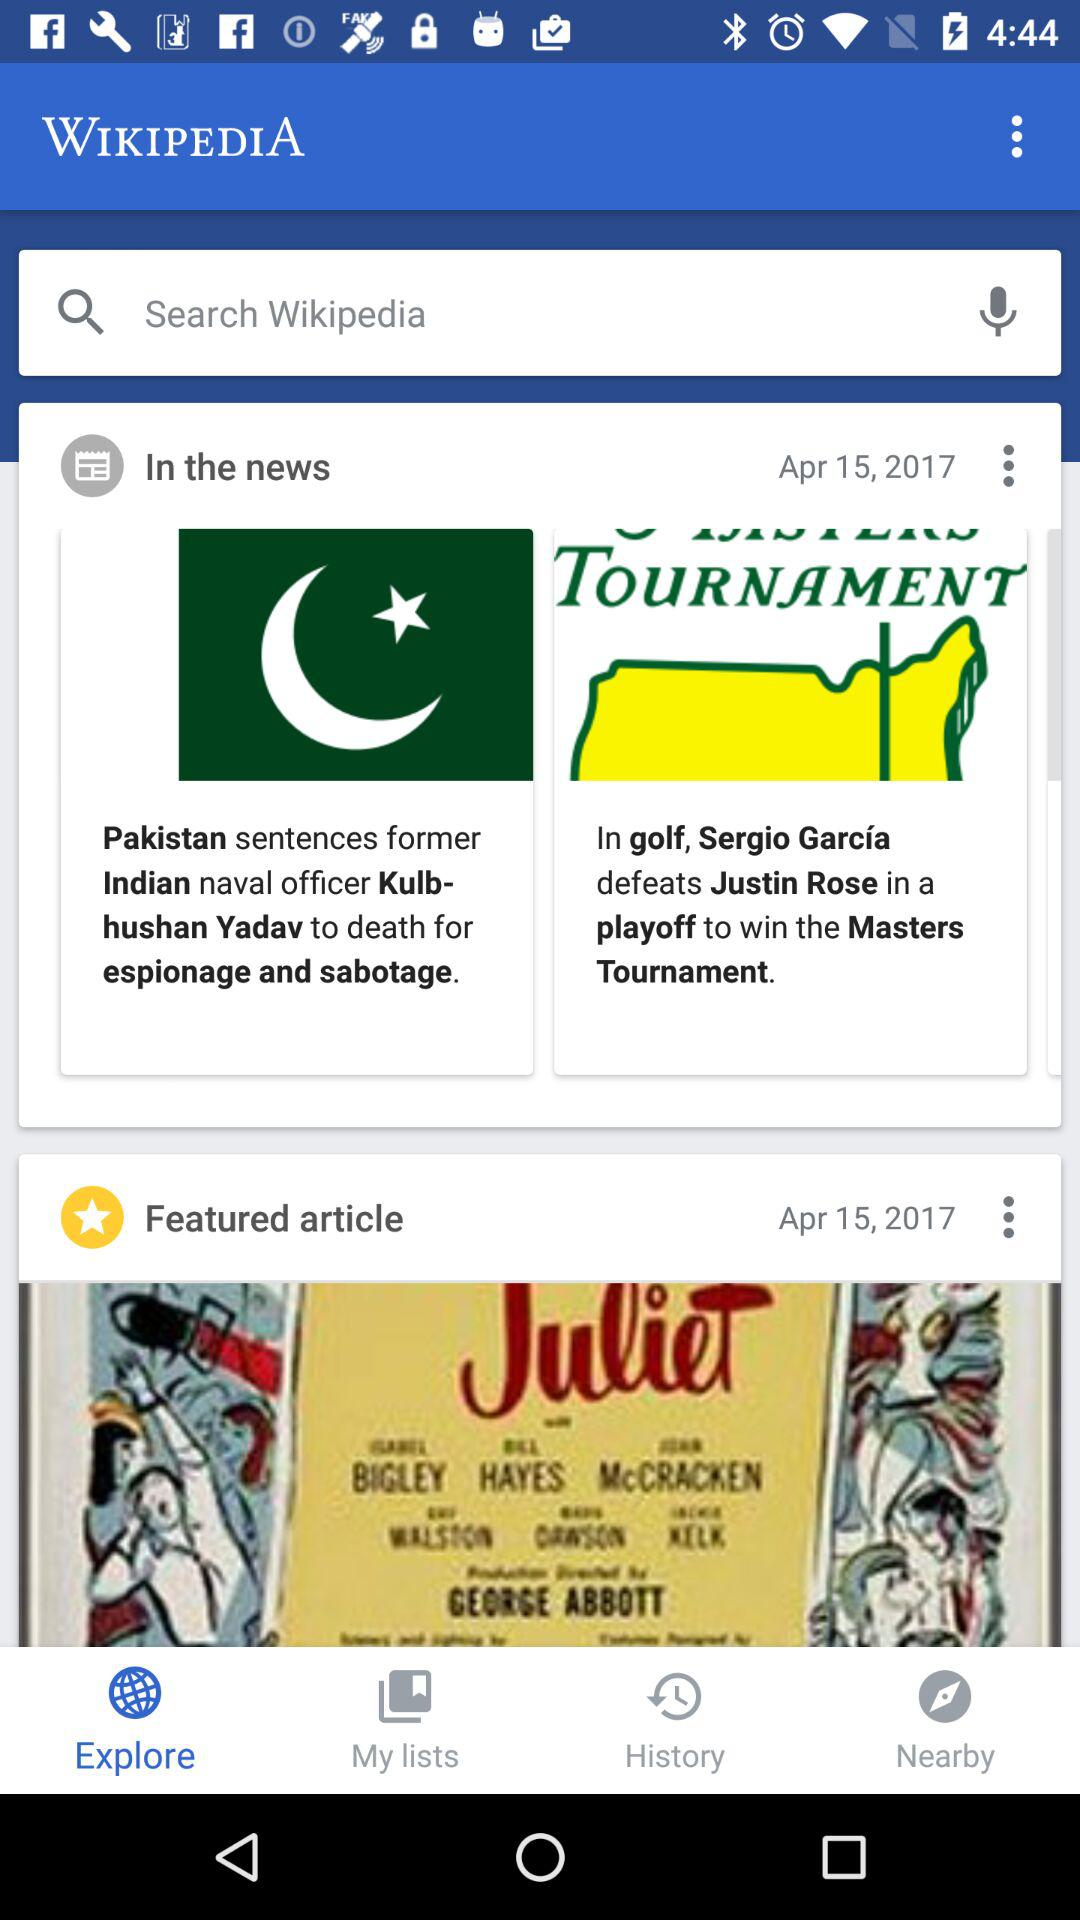What is the application name? The application name is "WIKIPEDIA". 